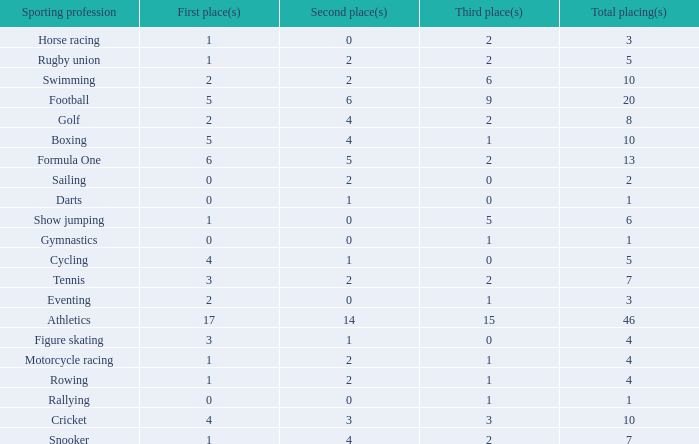How many second place showings does snooker have? 4.0. 